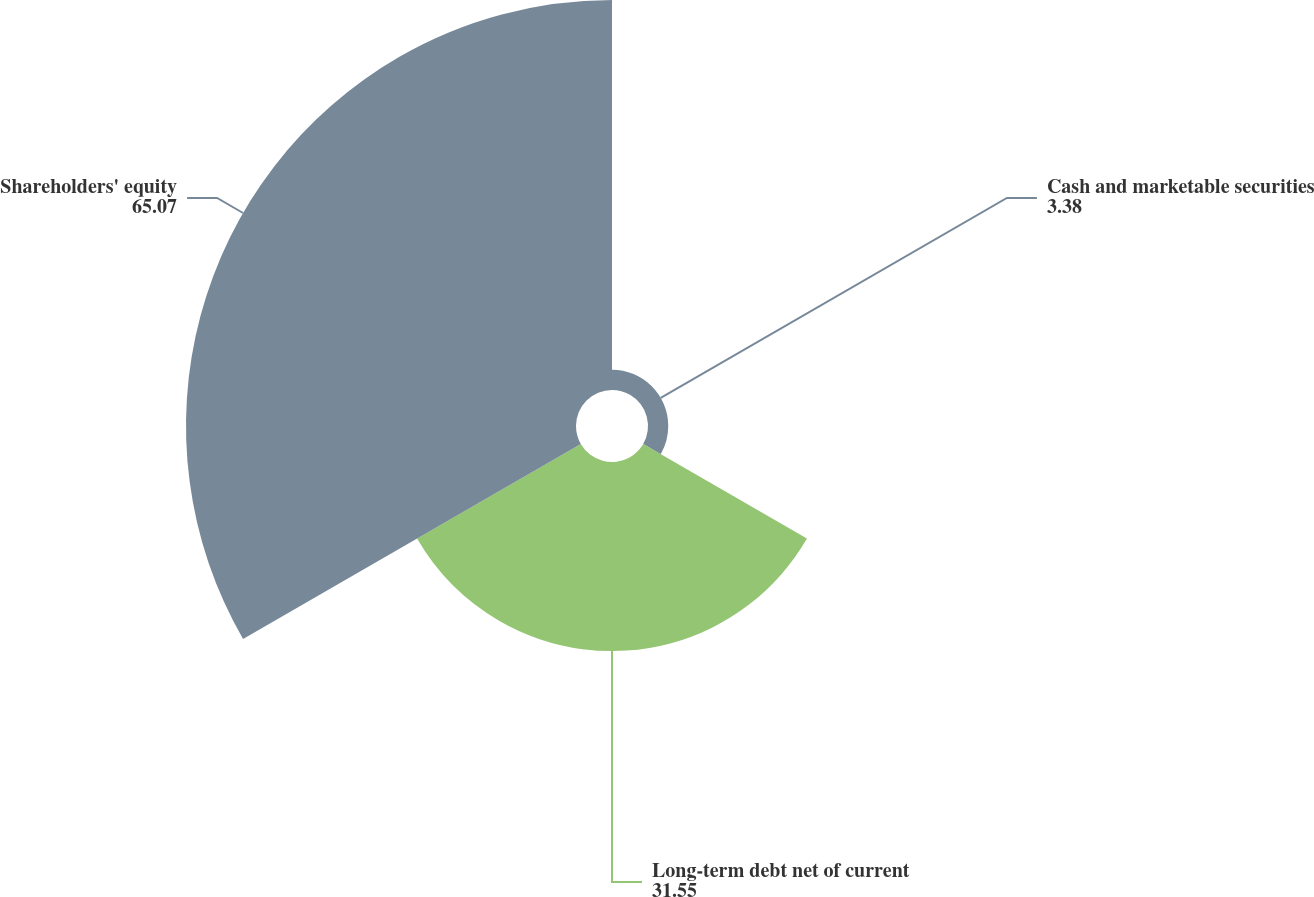Convert chart to OTSL. <chart><loc_0><loc_0><loc_500><loc_500><pie_chart><fcel>Cash and marketable securities<fcel>Long-term debt net of current<fcel>Shareholders' equity<nl><fcel>3.38%<fcel>31.55%<fcel>65.07%<nl></chart> 